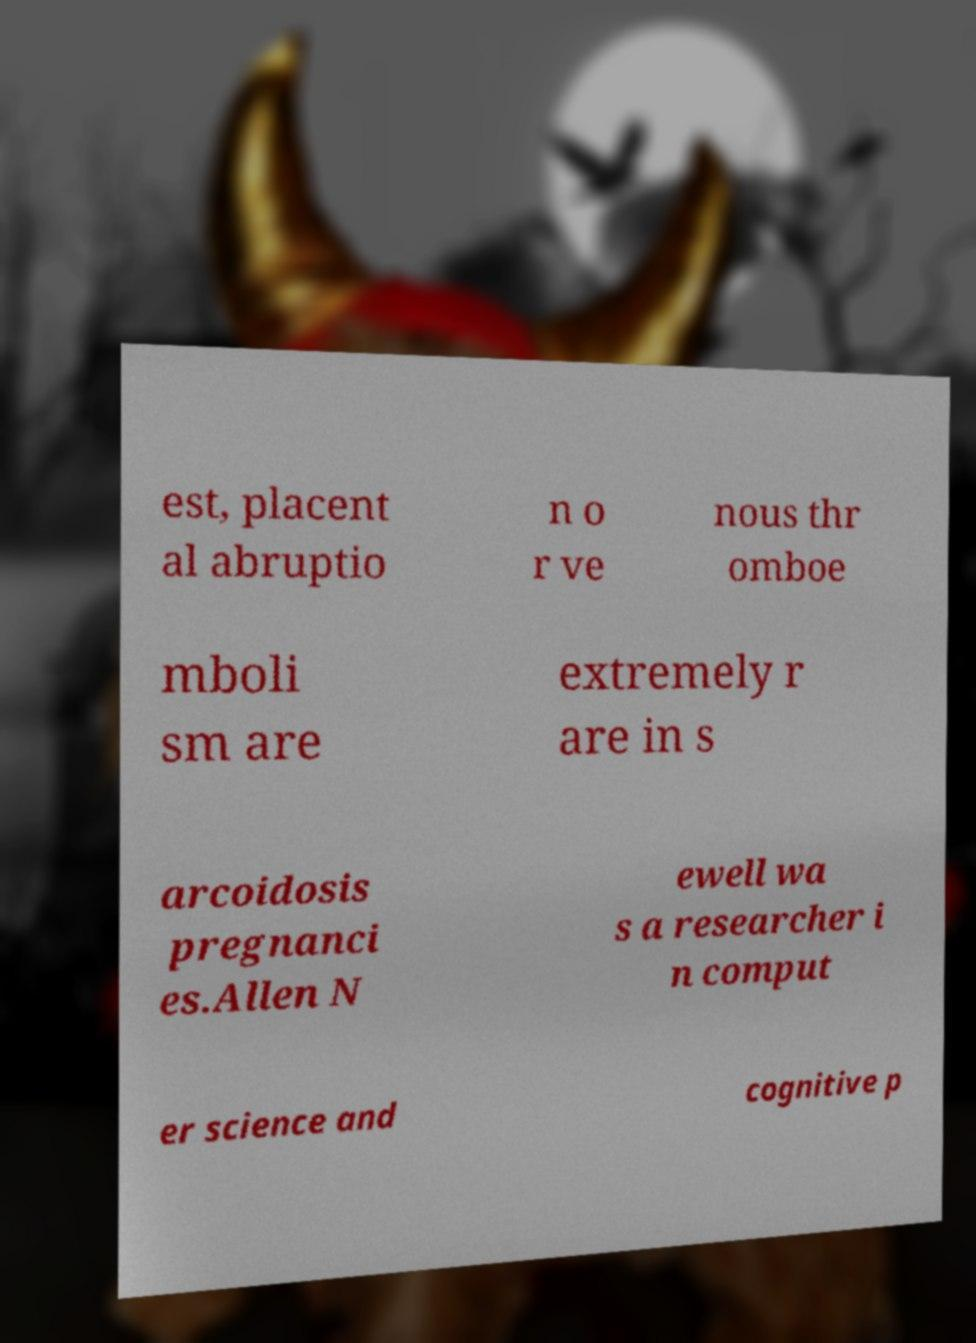What messages or text are displayed in this image? I need them in a readable, typed format. est, placent al abruptio n o r ve nous thr omboe mboli sm are extremely r are in s arcoidosis pregnanci es.Allen N ewell wa s a researcher i n comput er science and cognitive p 